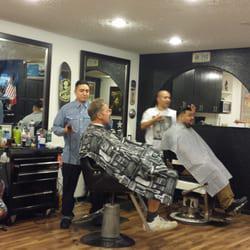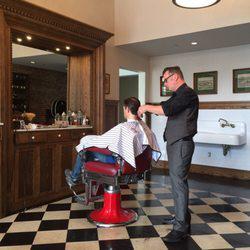The first image is the image on the left, the second image is the image on the right. Given the left and right images, does the statement "There are people in one image but not in the other image." hold true? Answer yes or no. No. The first image is the image on the left, the second image is the image on the right. Examine the images to the left and right. Is the description "In one of the images there is a checkered floor and in the other image there is a wooden floor." accurate? Answer yes or no. Yes. 